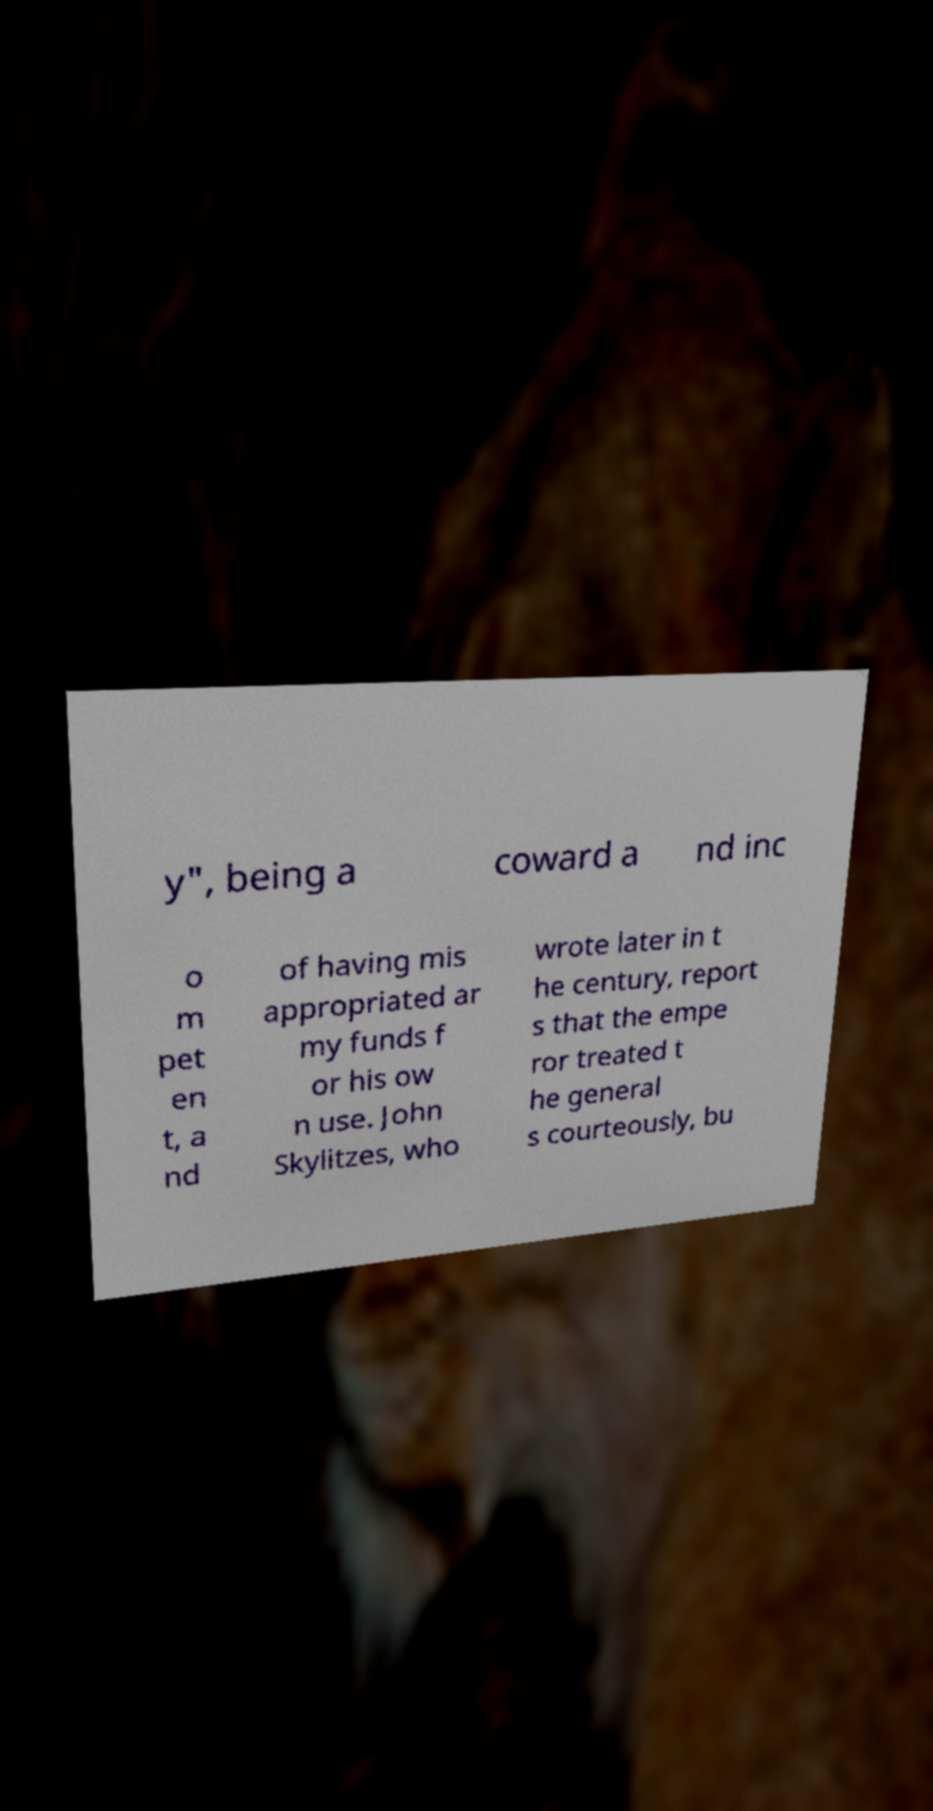Please identify and transcribe the text found in this image. y", being a coward a nd inc o m pet en t, a nd of having mis appropriated ar my funds f or his ow n use. John Skylitzes, who wrote later in t he century, report s that the empe ror treated t he general s courteously, bu 